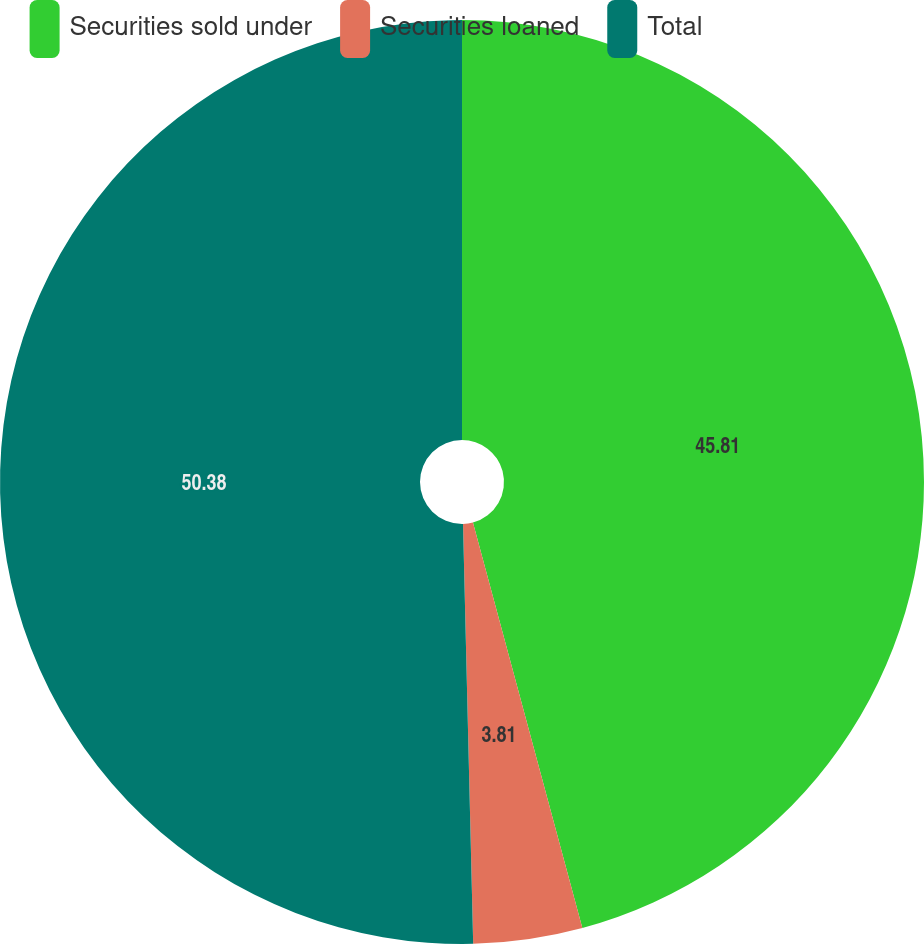Convert chart to OTSL. <chart><loc_0><loc_0><loc_500><loc_500><pie_chart><fcel>Securities sold under<fcel>Securities loaned<fcel>Total<nl><fcel>45.81%<fcel>3.81%<fcel>50.39%<nl></chart> 